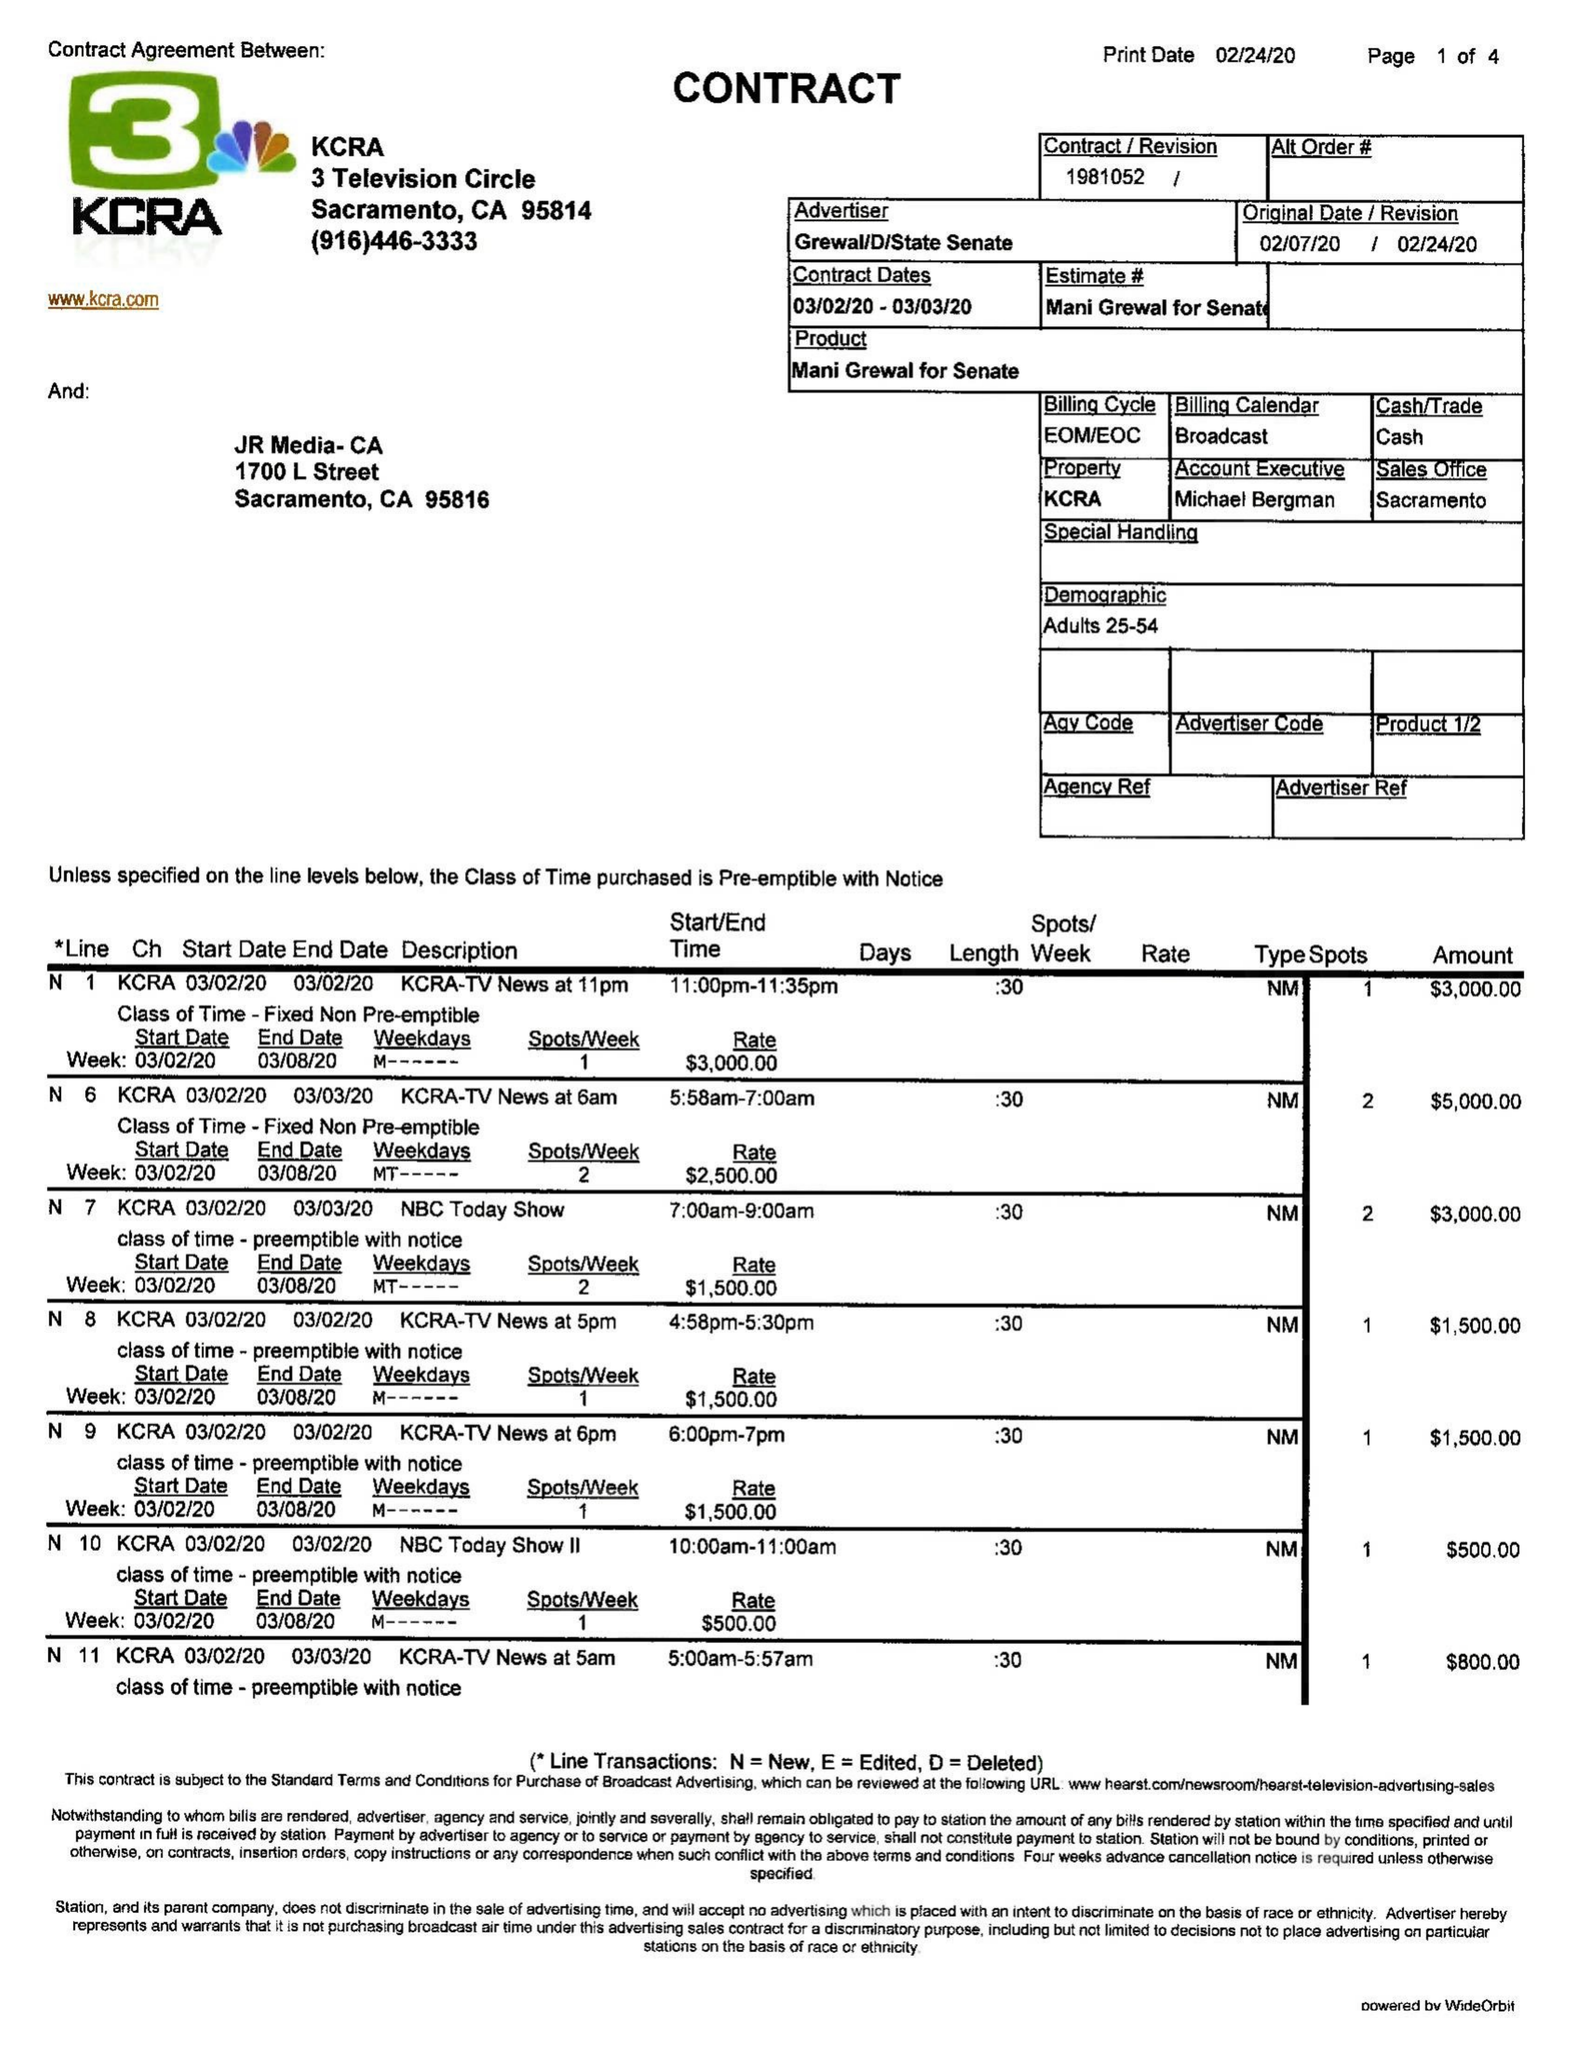What is the value for the flight_from?
Answer the question using a single word or phrase. 03/02/20 